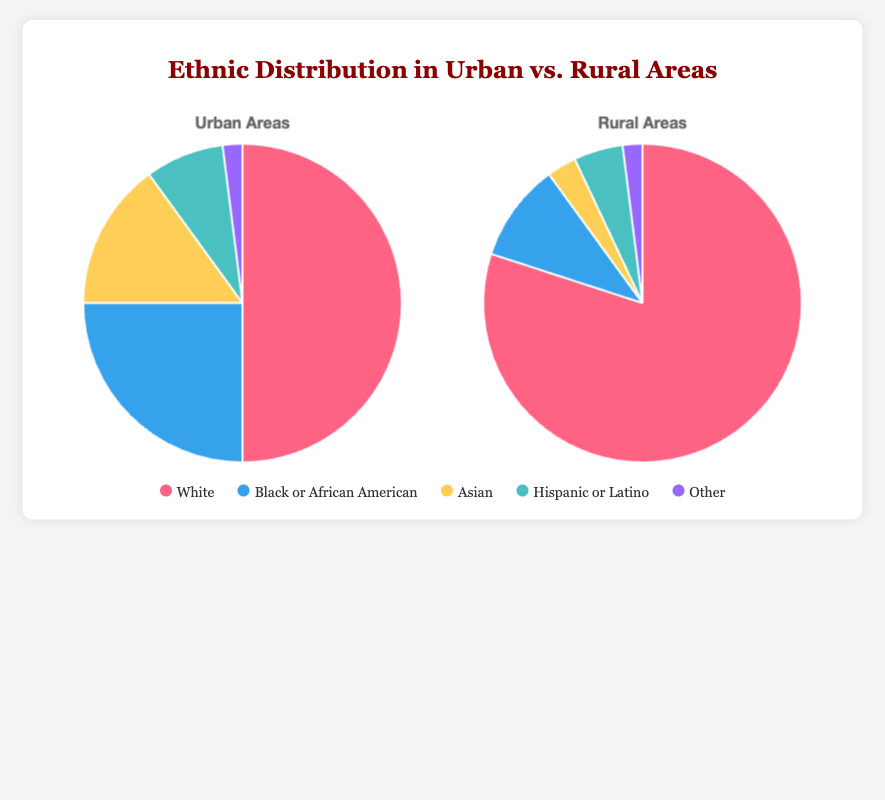What is the percentage of the Asian population in urban areas? The urban areas have a 15% Asian population as given directly by the pie chart data.
Answer: 15% Compare the percentage of the Hispanic or Latino population in urban and rural areas. In urban areas, the Hispanic or Latino population is 8%, while in rural areas it is 5%. Comparing these, the urban areas have a higher percentage of Hispanic or Latino individuals.
Answer: Urban areas have a higher percentage, 8% vs 5% Which ethnic group has the same percentage in both urban and rural areas? The 'Other' category has 2% in both urban and rural areas according to the pie chart.
Answer: Other Calculate the difference in the percentage of the White population between urban and rural areas. The White population is 80% in rural areas and 50% in urban areas. The difference is 80% - 50% = 30%.
Answer: 30% How does the visual representation of the Asian population differ between urban and rural areas? In the urban areas pie chart, the slice for the Asian population is much larger compared to the slice in the rural areas pie chart, indicating a higher percentage.
Answer: Larger in urban areas Which ethnic group has the largest representation in urban areas, and what is its percentage? The White population has the largest representation in urban areas with 50%.
Answer: White, 50% What is the combined percentage of the Black or African American and Asian populations in urban areas? The Black or African American population is 25% and the Asian population is 15%. Combined, this is 25% + 15% = 40%.
Answer: 40% Determine the ratio of the White population percentage in rural areas to that in urban areas. The White population is 80% in rural areas and 50% in urban areas. Thus, the ratio is 80/50 = 1.6.
Answer: 1.6 